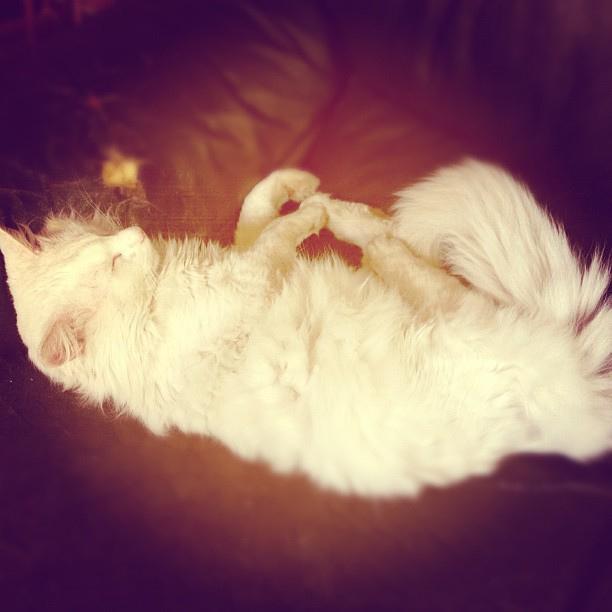How many cats are in the picture?
Give a very brief answer. 1. How many zebras are there?
Give a very brief answer. 0. 